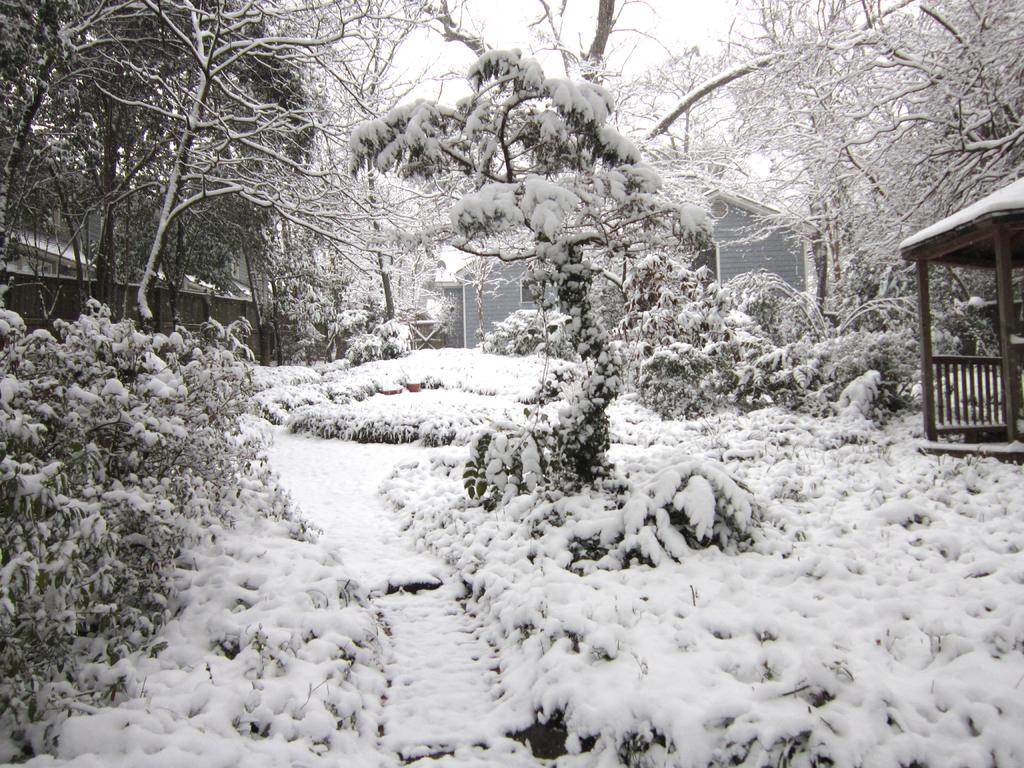What is the condition of the plants and trees in the image? The plants and trees are covered with snow in the image. What type of structure can be seen in the image? There is a house in the image. Are there any other outdoor structures visible in the image? Yes, there is a gazebo in the image. What can be seen in the background of the image? The sky is visible in the background of the image. Where is the desk located in the image? There is no desk present in the image. How does the toad feel about the snow-covered plants and trees? There is no toad present in the image, so it is not possible to determine how it might feel about the snow-covered plants and trees. 